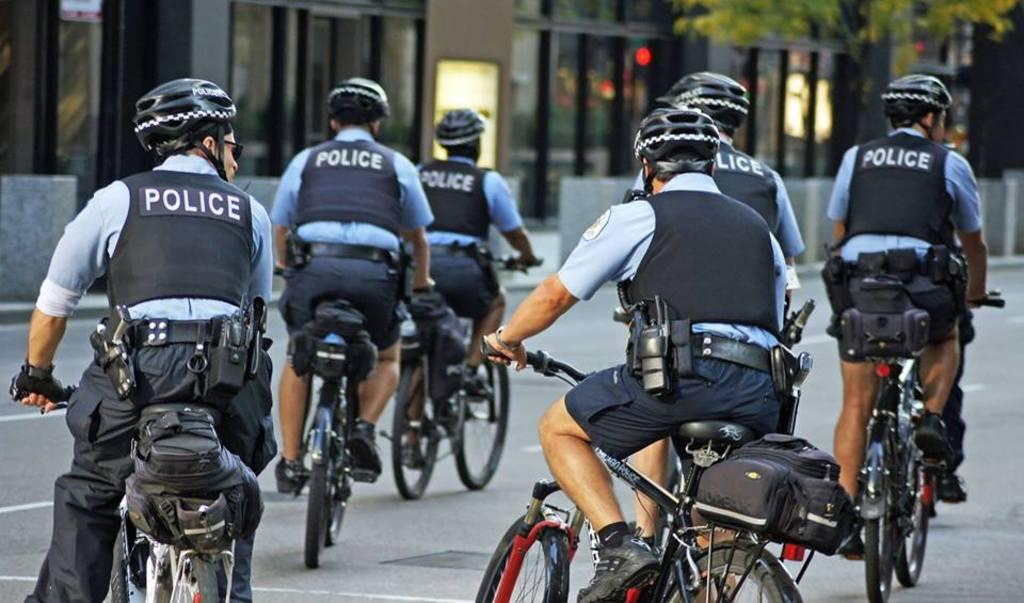Who or what can be seen in the image? There are people in the image. What are the people doing in the image? The people are sitting on bicycles. Where are the bicycles located in the image? The bicycles are on the road. What type of iron can be seen in the image? There is no iron present in the image. How many times does the person on the left shake their hand in the image? There is no indication of anyone shaking their hand in the image. 